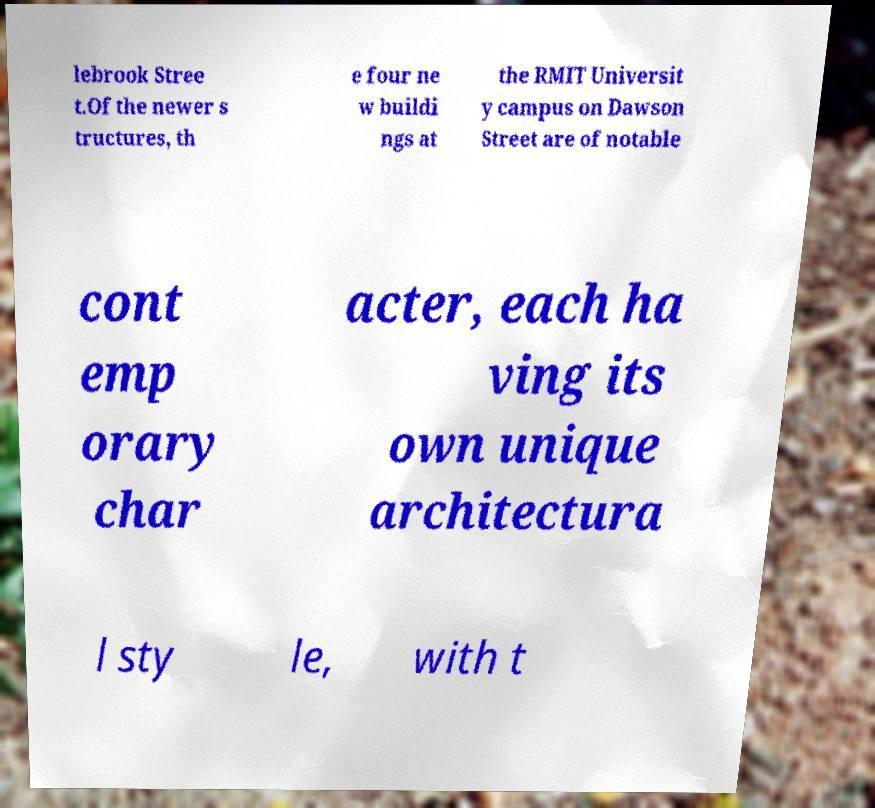What messages or text are displayed in this image? I need them in a readable, typed format. lebrook Stree t.Of the newer s tructures, th e four ne w buildi ngs at the RMIT Universit y campus on Dawson Street are of notable cont emp orary char acter, each ha ving its own unique architectura l sty le, with t 